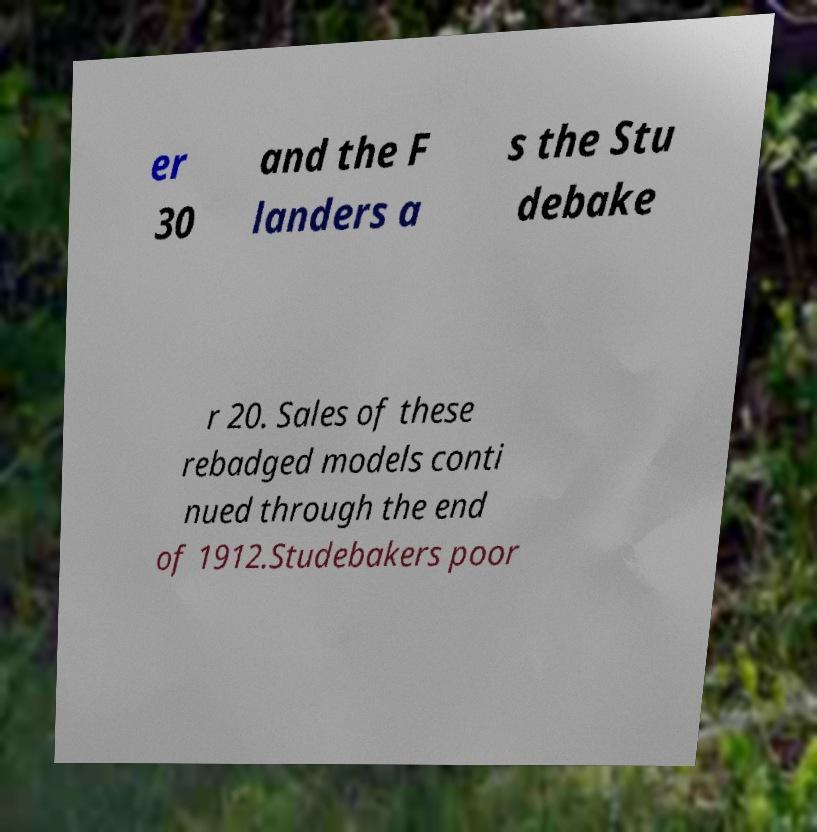Could you extract and type out the text from this image? er 30 and the F landers a s the Stu debake r 20. Sales of these rebadged models conti nued through the end of 1912.Studebakers poor 